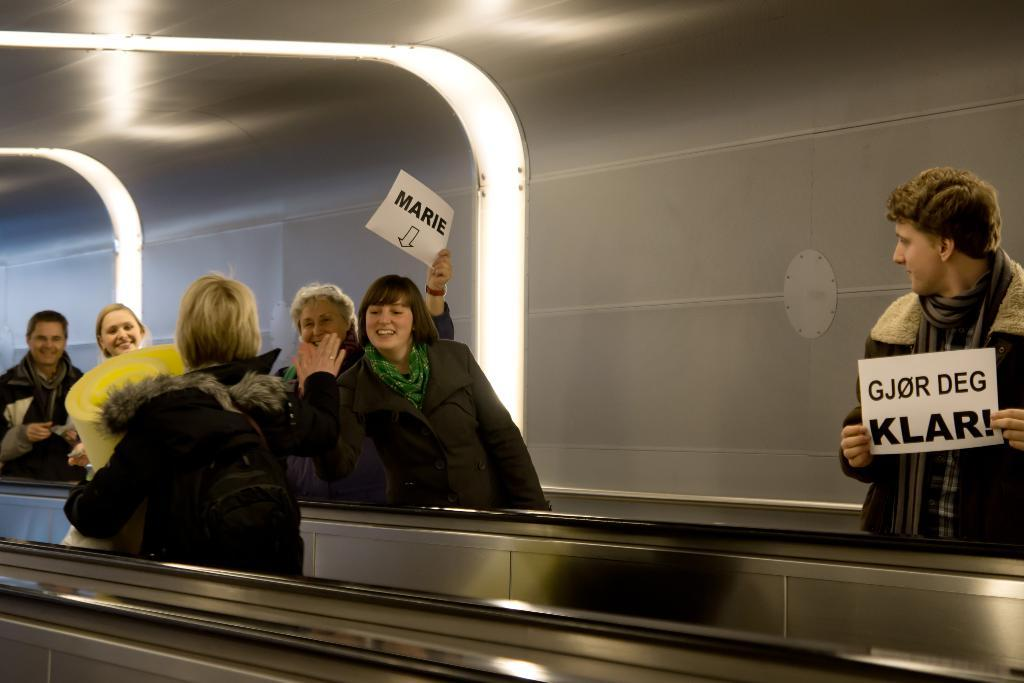What is the main subject of the image? The main subject of the image is a group of people. What are some of the people in the group doing? Some people in the group are holding posters. What is the general mood of the people in the image? The people in the group are smiling, which suggests a positive mood. What can be seen in the background of the image? There are lights and a wall in the background of the image. What holiday are the people in the image celebrating? There is no indication of a holiday being celebrated in the image. What is the condition of the sisters in the image? There are no sisters present in the image, so it is not possible to determine their condition. 